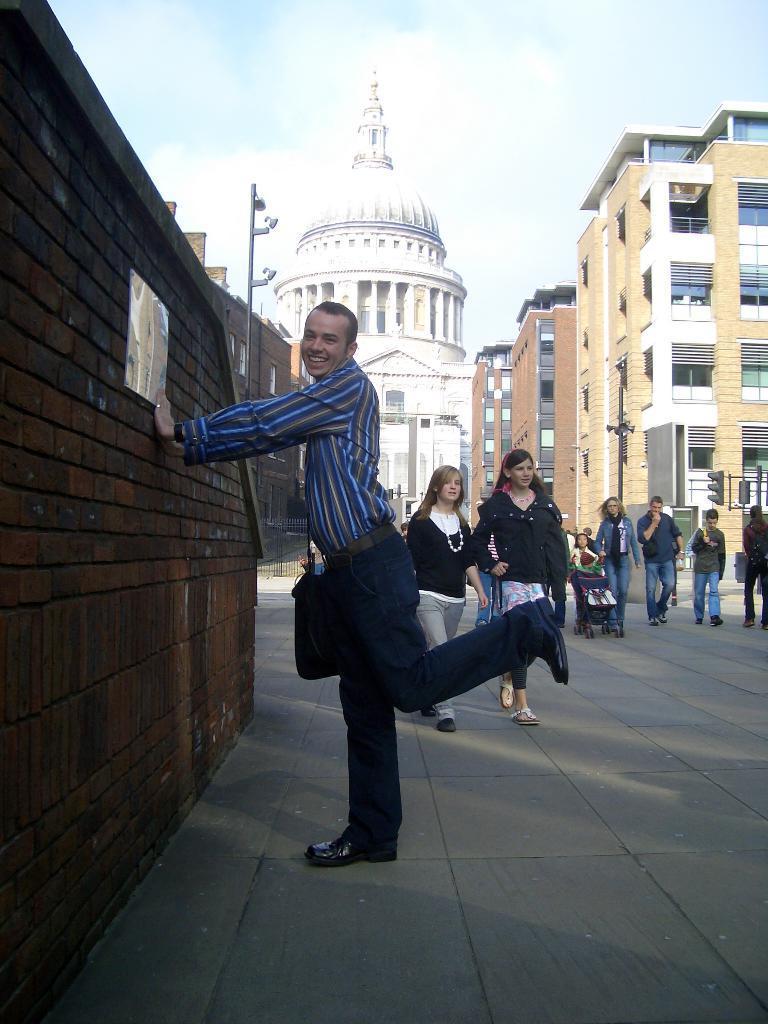In one or two sentences, can you explain what this image depicts? In this image there is a road. There is a wall on the left side. There are people walking. There are building on the right side. There is a white color building in the background. There is a sky. There are signal poles. 